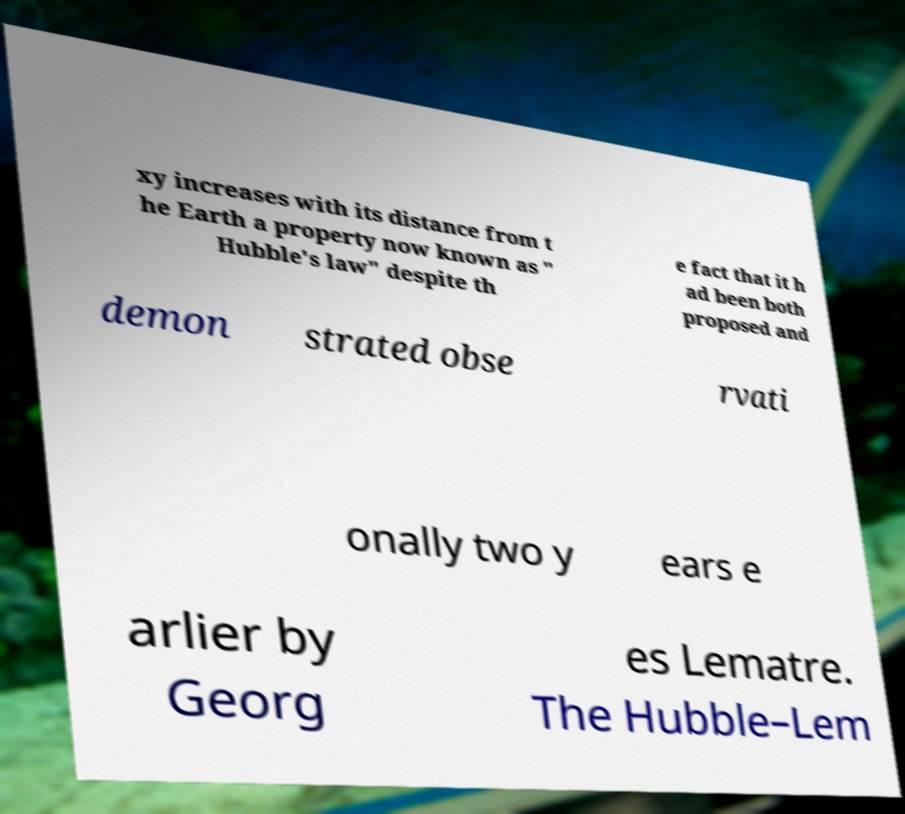What messages or text are displayed in this image? I need them in a readable, typed format. xy increases with its distance from t he Earth a property now known as " Hubble's law" despite th e fact that it h ad been both proposed and demon strated obse rvati onally two y ears e arlier by Georg es Lematre. The Hubble–Lem 